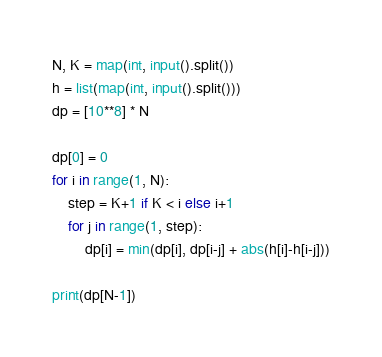<code> <loc_0><loc_0><loc_500><loc_500><_Python_>N, K = map(int, input().split())
h = list(map(int, input().split()))
dp = [10**8] * N

dp[0] = 0
for i in range(1, N):
    step = K+1 if K < i else i+1
    for j in range(1, step):
        dp[i] = min(dp[i], dp[i-j] + abs(h[i]-h[i-j]))
        
print(dp[N-1])</code> 